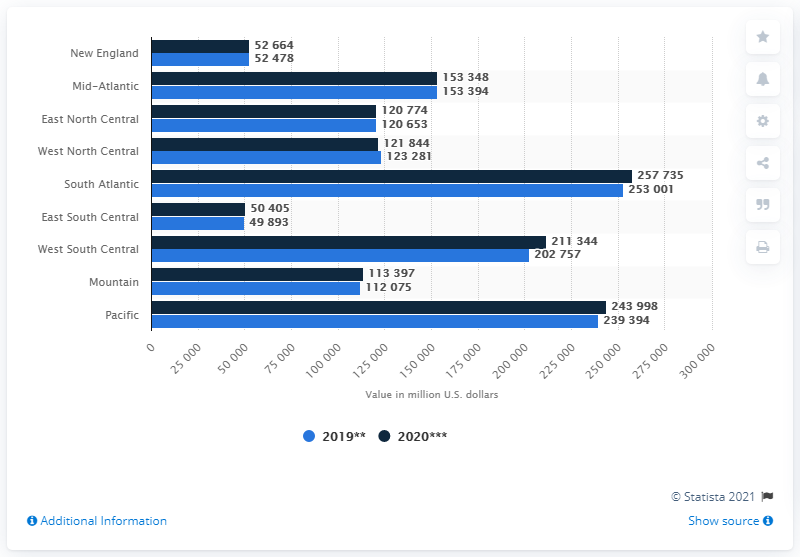Outline some significant characteristics in this image. The estimated value of construction in the New England region in 2020 is approximately 524,780 dollars. 